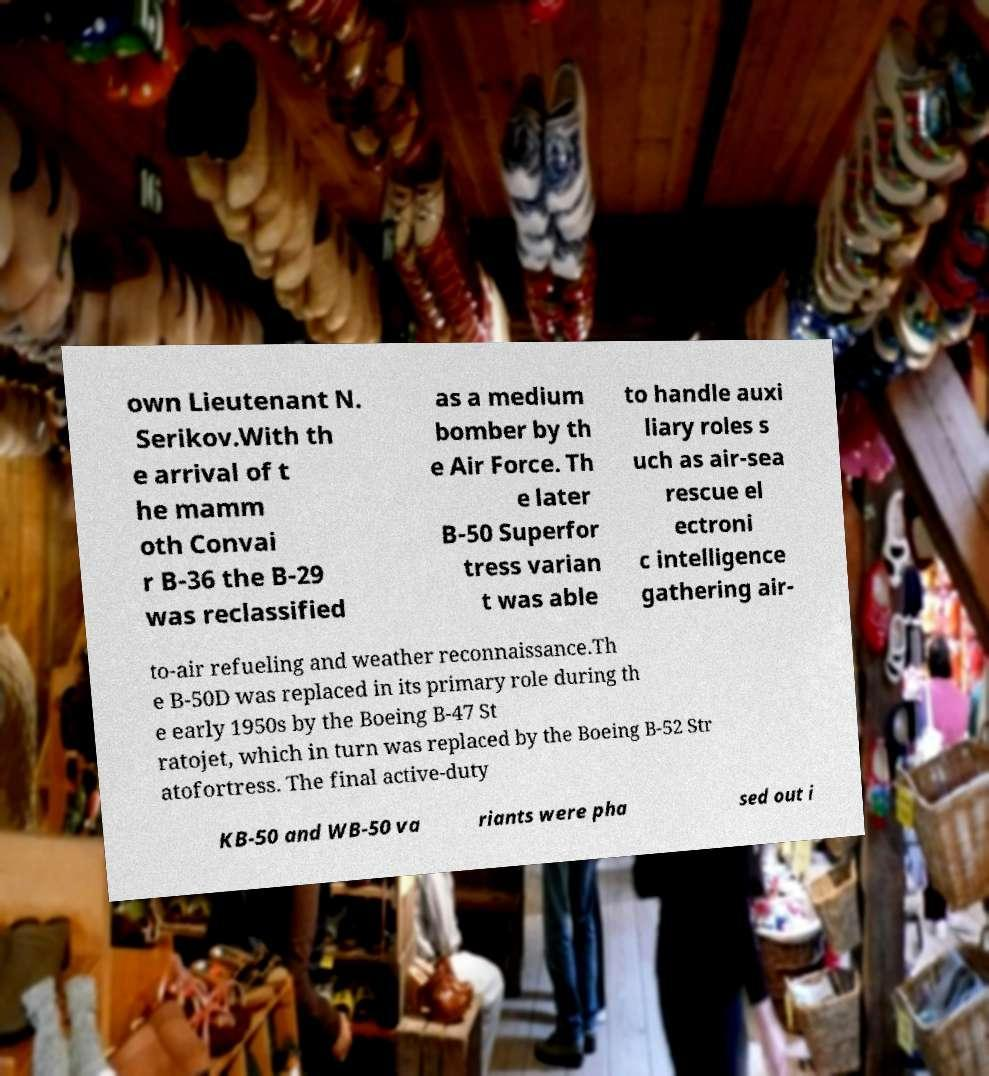I need the written content from this picture converted into text. Can you do that? own Lieutenant N. Serikov.With th e arrival of t he mamm oth Convai r B-36 the B-29 was reclassified as a medium bomber by th e Air Force. Th e later B-50 Superfor tress varian t was able to handle auxi liary roles s uch as air-sea rescue el ectroni c intelligence gathering air- to-air refueling and weather reconnaissance.Th e B-50D was replaced in its primary role during th e early 1950s by the Boeing B-47 St ratojet, which in turn was replaced by the Boeing B-52 Str atofortress. The final active-duty KB-50 and WB-50 va riants were pha sed out i 